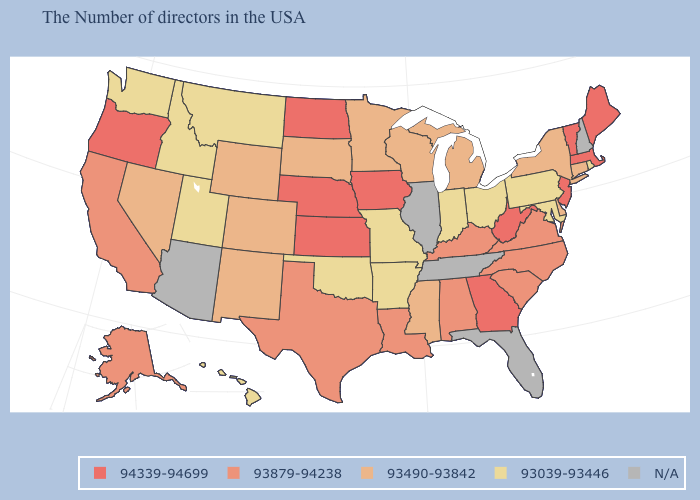What is the highest value in states that border Minnesota?
Concise answer only. 94339-94699. What is the value of North Carolina?
Give a very brief answer. 93879-94238. Among the states that border Montana , which have the lowest value?
Be succinct. Idaho. What is the lowest value in the USA?
Answer briefly. 93039-93446. Among the states that border South Carolina , does North Carolina have the lowest value?
Answer briefly. Yes. What is the value of Illinois?
Be succinct. N/A. Among the states that border Rhode Island , which have the lowest value?
Be succinct. Connecticut. Which states hav the highest value in the South?
Write a very short answer. West Virginia, Georgia. Does the first symbol in the legend represent the smallest category?
Quick response, please. No. Which states have the lowest value in the USA?
Concise answer only. Rhode Island, Maryland, Pennsylvania, Ohio, Indiana, Missouri, Arkansas, Oklahoma, Utah, Montana, Idaho, Washington, Hawaii. Is the legend a continuous bar?
Short answer required. No. What is the value of South Dakota?
Concise answer only. 93490-93842. Among the states that border Vermont , does New York have the highest value?
Give a very brief answer. No. What is the highest value in the West ?
Be succinct. 94339-94699. 